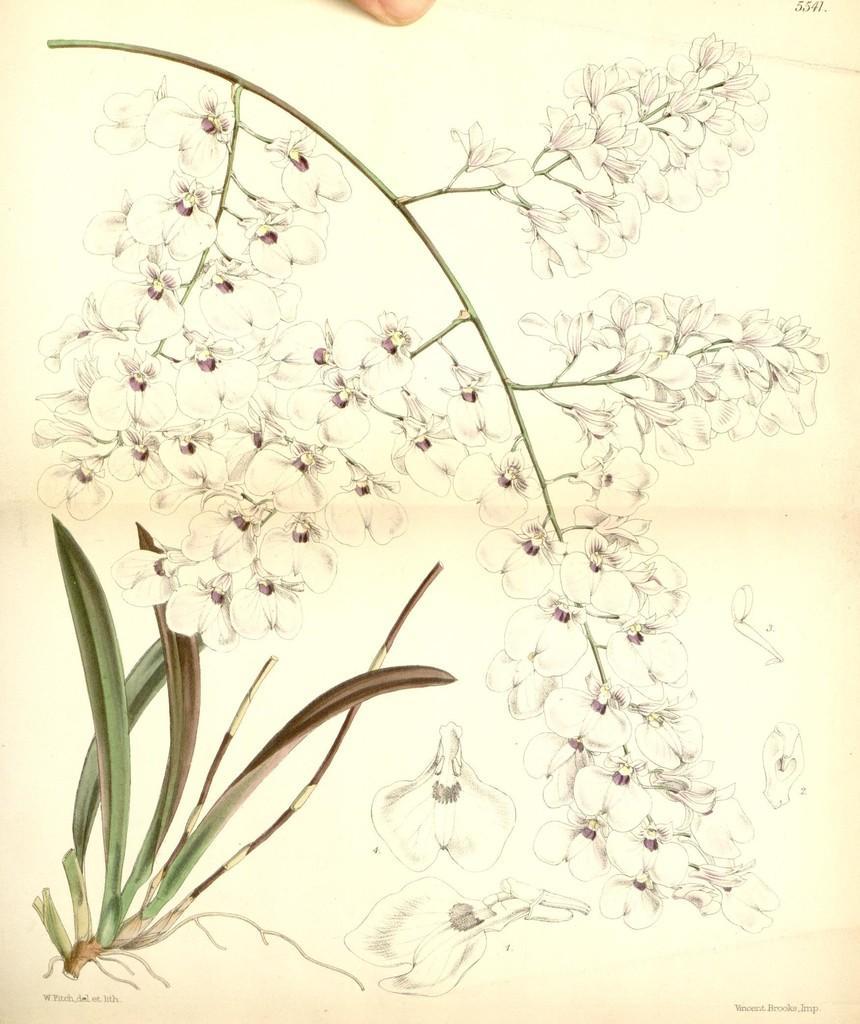How would you summarize this image in a sentence or two? In this image there are paintings of a plant. In the center there are flowers to a stem. At the top there is a nail to a finger. 